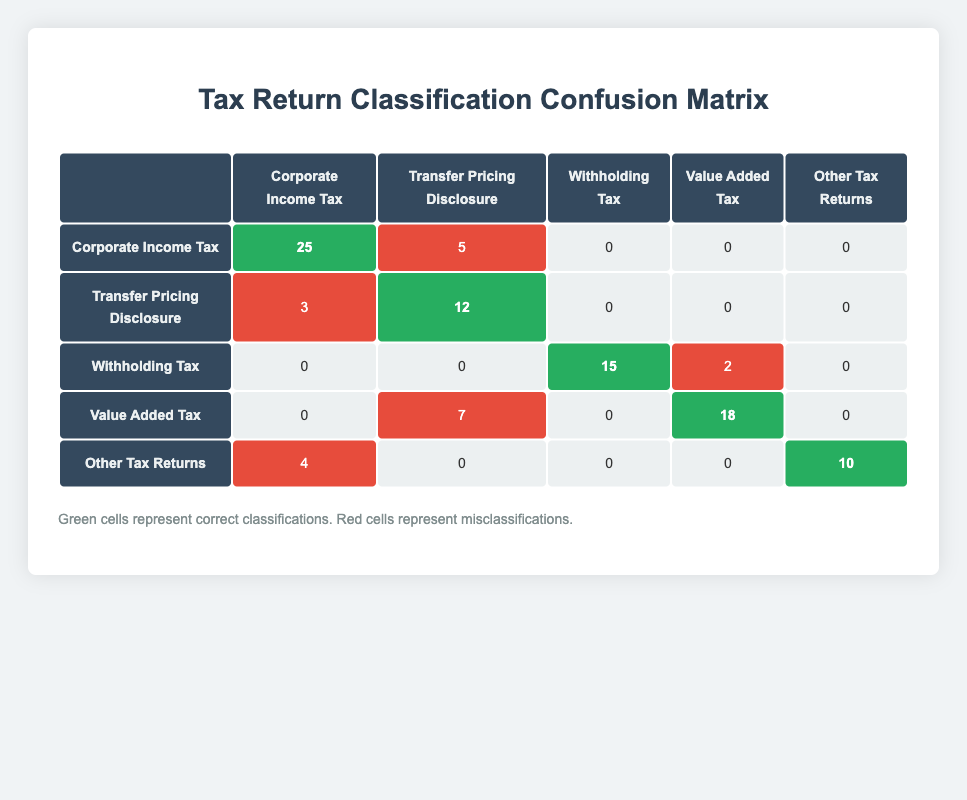What is the count of correctly classified Corporate Income Tax returns? In the confusion matrix, the highlight cell for Corporate Income Tax shows a count of 25. This represents the number of correctly classified returns for this category.
Answer: 25 How many Transfer Pricing Disclosure returns were misclassified as Corporate Income Tax? Looking at the confusion matrix, the red cell under Corporate Income Tax for Transfer Pricing Disclosure shows a count of 5, indicating five misclassified returns.
Answer: 5 What is the total number of Withholding Tax returns filed? From the table, there is a count of 15 correctly classified returns and 2 misclassified as Value Added Tax for Withholding Tax. Thus, the total is 15 + 2 = 17.
Answer: 17 Did any returns for Value Added Tax get classified as Withholding Tax? Reviewing the confusion matrix, there is a red cell under Withholding Tax for Value Added Tax with a count of 2, therefore, yes, there are misclassified returns.
Answer: Yes What is the difference between the correctly classified and misclassified Value Added Tax returns? The correct classification for Value Added Tax is 18, while the misclassified count is 7 (classified as Transfer Pricing Disclosure). The difference is 18 - 7 = 11.
Answer: 11 